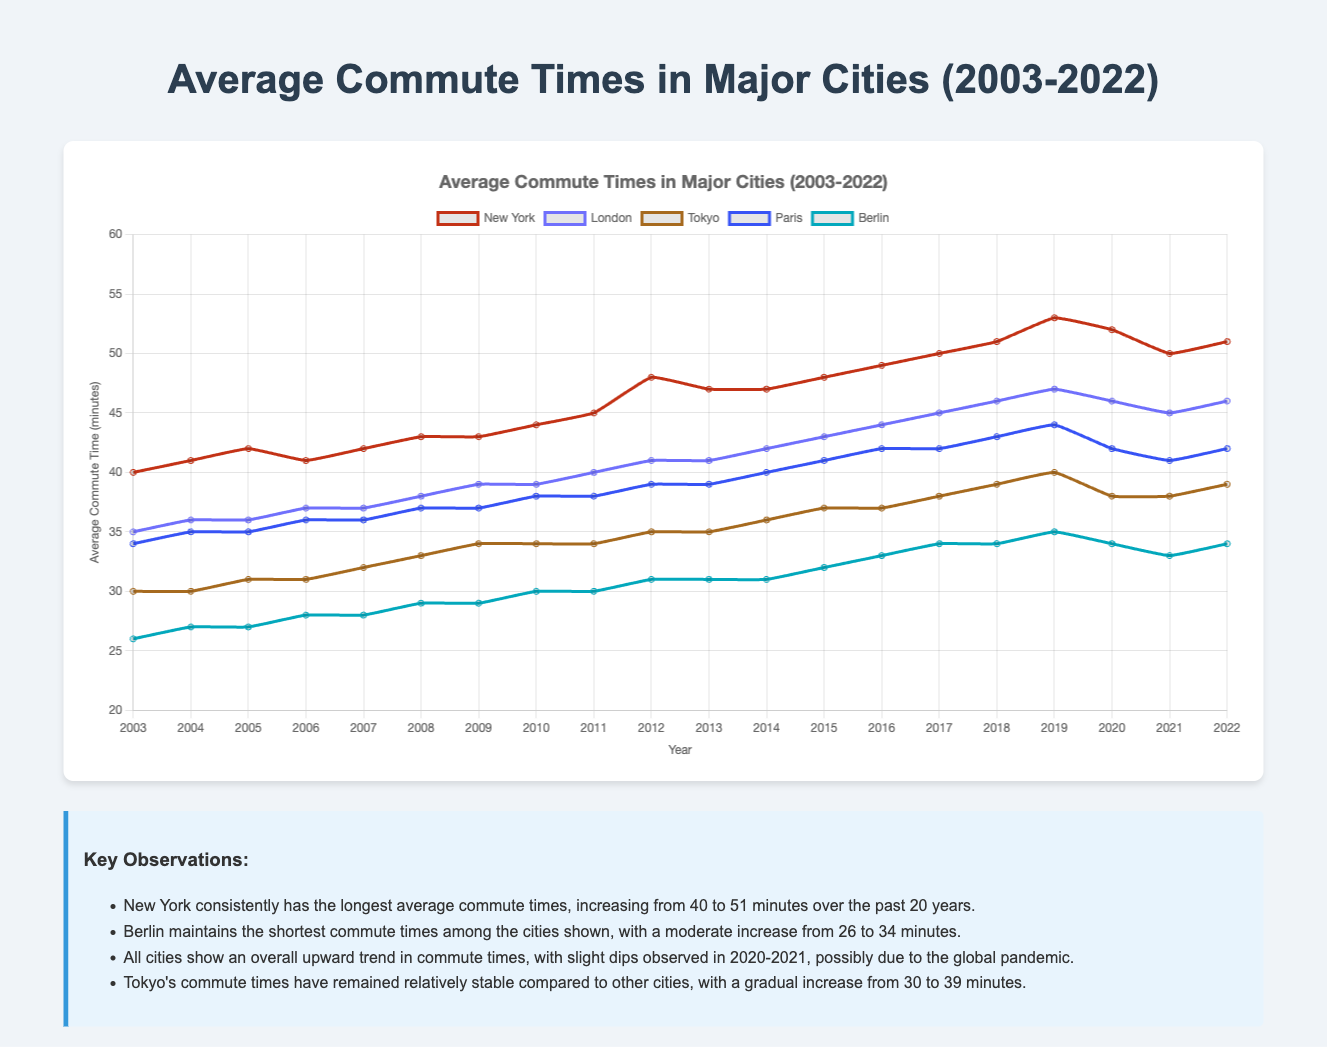What is the trend in commute times for New York over the 20-year period? The commute times in New York show an overall increasing trend. Starting from 40 minutes in 2003, it gradually rises to 51 minutes in 2022. There are some fluctuations, with the peak occurring in 2019 at 53 minutes, followed by a slight drop in the subsequent years.
Answer: Increasing Which city had the shortest commute time in 2022? To find the shortest commute time in 2022, look at the data for each city in that year. New York (51), London (46), Tokyo (39), Paris (42), and Berlin (34). Berlin has the shortest commute time at 34 minutes.
Answer: Berlin By how many minutes did the average commute time in London increase from 2003 to 2022? The commute time in London was 35 minutes in 2003 and 46 minutes in 2022. The increase is calculated as 46 - 35 = 11 minutes.
Answer: 11 minutes Compare the commute times of Tokyo and Paris in 2019. Which city had longer commute times and by how much? In 2019, Tokyo's commute time was 40 minutes, and Paris’s was 44 minutes. Paris had longer commute times by 44 - 40 = 4 minutes.
Answer: Paris, 4 minutes What was the highest commute time recorded for any city in any year, based on the data? The highest commute time among all cities and years is found through comparison. New York’s highest recorded is 53 minutes in 2019, which is the highest among all.
Answer: 53 minutes How did the average commute time in Berlin change during the global pandemic years (2020-2021)? In 2020, Berlin’s commute time was 34 minutes, and in 2021, it was 33 minutes. The change is found by 33 - 34 = -1 minute, indicating a decrease.
Answer: Decrease by 1 minute What is the average commute time across all cities in 2022? Sum the commute times of all cities in 2022 and divide by the number of cities: (51 + 46 + 39 + 42 + 34) / 5 = 42.4 minutes.
Answer: 42.4 minutes Between which years did New York see the largest increase in commute time? Examining yearly differences in New York's commute times, the largest increase is between 2011 and 2012 (45 to 48 minutes), an increase of 3 minutes.
Answer: 2011 to 2012 